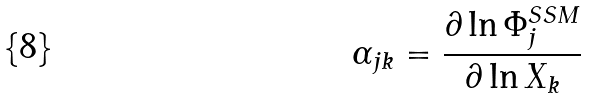Convert formula to latex. <formula><loc_0><loc_0><loc_500><loc_500>\alpha _ { j k } = \frac { \partial \ln \Phi _ { j } ^ { S S M } } { \partial \ln X _ { k } }</formula> 